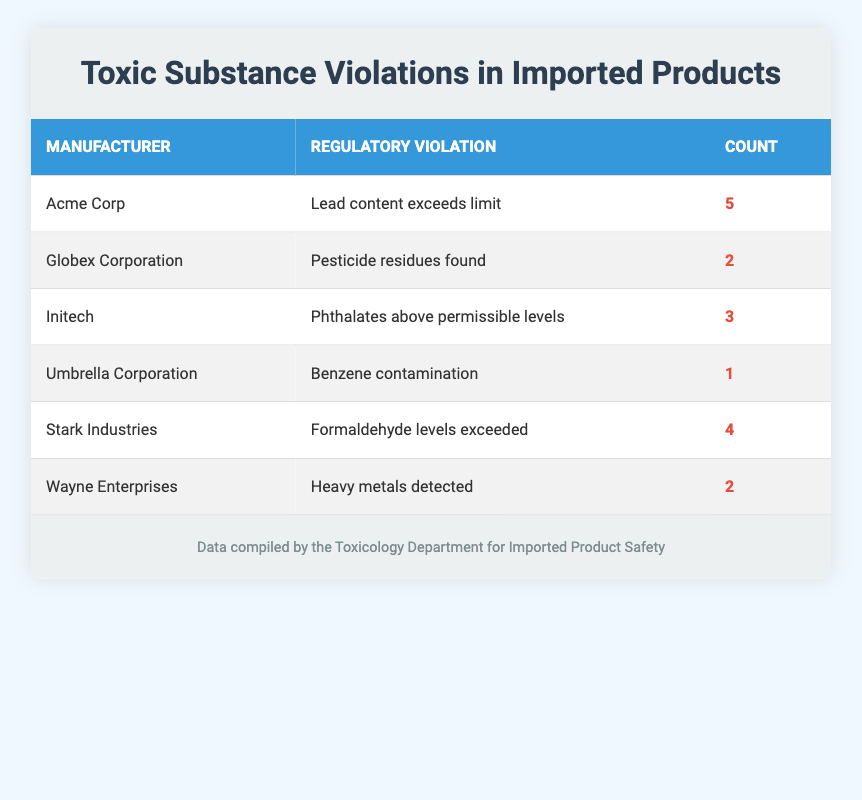What is the total number of regulatory violations reported in the table? To find the total number of violations, we need to sum up the counts from each manufacturer: 5 (Acme Corp) + 2 (Globex Corporation) + 3 (Initech) + 1 (Umbrella Corporation) + 4 (Stark Industries) + 2 (Wayne Enterprises) = 17.
Answer: 17 Which manufacturer has reported the highest number of violations? Acme Corp has the highest count of 5 violations. By comparing the counts of each manufacturer: 5 (Acme Corp), 2 (Globex Corporation), 3 (Initech), 1 (Umbrella Corporation), 4 (Stark Industries), and 2 (Wayne Enterprises), Acme Corp has the highest.
Answer: Acme Corp Is there a manufacturer that reported no violations? By looking at the table, all manufacturers have reported at least one violation. There are no manufacturers listed with a count of zero violations.
Answer: No What is the average number of violations across the manufacturers listed? To calculate the average, we take the total number of violations (17) and divide it by the number of manufacturers (6): 17/6 = approximately 2.83.
Answer: 2.83 How many more violations did Acme Corp report compared to Umbrella Corporation? Acme Corp reported 5 violations, while Umbrella Corporation reported 1 violation. The difference is: 5 - 1 = 4 more violations.
Answer: 4 Are there any manufacturers that reported the same number of violations? Yes, both Wayne Enterprises and Globex Corporation reported 2 violations each.
Answer: Yes Which regulatory violation has the lowest count? The category with the lowest count is Benzene contamination reported by Umbrella Corporation with a count of 1. Comparing all the violations, Umbrella Corporation is the only one with a count of 1.
Answer: Benzene contamination How many manufacturers have violations related to heavy metals or pesticides? Heavy metals were detected in Wayne Enterprises and pesticide residues were found in Globex Corporation. Thus, there are 2 manufacturers with these violations.
Answer: 2 If we combine the violation counts for phthalates and formaldehyde, what is the total? Phthalates have a count of 3 (Initech) and formaldehyde levels exceeded counts 4 (Stark Industries). Summing these gives us: 3 + 4 = 7.
Answer: 7 